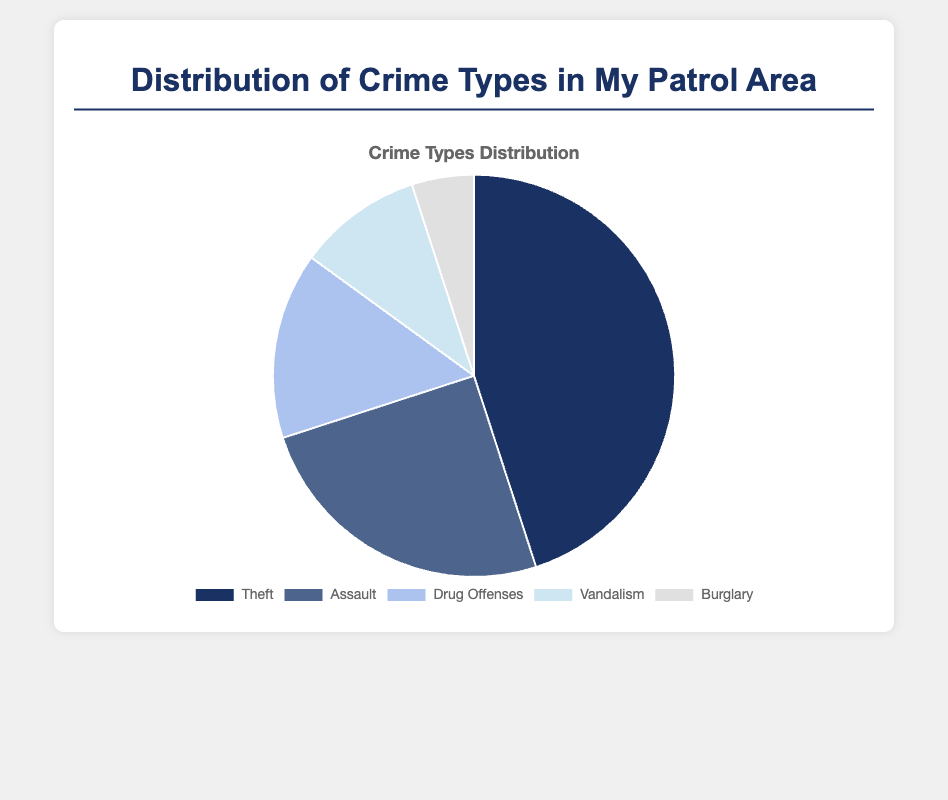Which crime type has the highest occurrence? The pie chart shows the distribution of various crime types. By visually assessing the sections, Theft has the largest section, indicating it has the highest occurrence.
Answer: Theft How many more Theft incidents are there compared to Burglary incidents? From the pie chart, Theft has 45 incidents and Burglary has 5 incidents. The difference is calculated as 45 - 5.
Answer: 40 Which two crime types combined make up half of the total incidents? Adding the incidents of Theft (45) and Assault (25), we get 70. Since the total number of incidents is 100, these two crime types combined (70%) almost make up three-fourths of the total. The closest set that makes up half is 45 (Theft) + 15 (Drug Offenses) = 60, which is more than half.
Answer: There is no exact pair Which crime type occupies the smallest section of the pie chart? By observing the size of the sections, Burglary occupies the smallest section.
Answer: Burglary What is the total number of incidents for non-violent crimes? Non-violent crimes in the chart are Theft, Drug Offenses, and Vandalism. Adding their numbers gives 45 + 15 + 10 = 70.
Answer: 70 If Vandalism incidents increased by 50%, how many total incidents would there be in the chart? Currently, Vandalism has 10 incidents. An increase of 50% means an additional 5 incidents, making it 10 + 5 = 15. The new total number of incidents would be 45 (Theft) + 25 (Assault) + 15 (Drug Offenses) + 15 (Vandalism) + 5 (Burglary) = 105.
Answer: 105 What percentage of the total does the Assault category represent? Assault incidents are 25. The total number of incidents is 100. The percentage is (25/100) * 100 = 25%.
Answer: 25% Which two crime types have an equal amount if combined? Vandalism and Drug Offenses together have incidents totaling 10 + 15 = 25. This equals the number of incidents for Assault, which also has 25.
Answer: Vandalism and Drug Offenses 